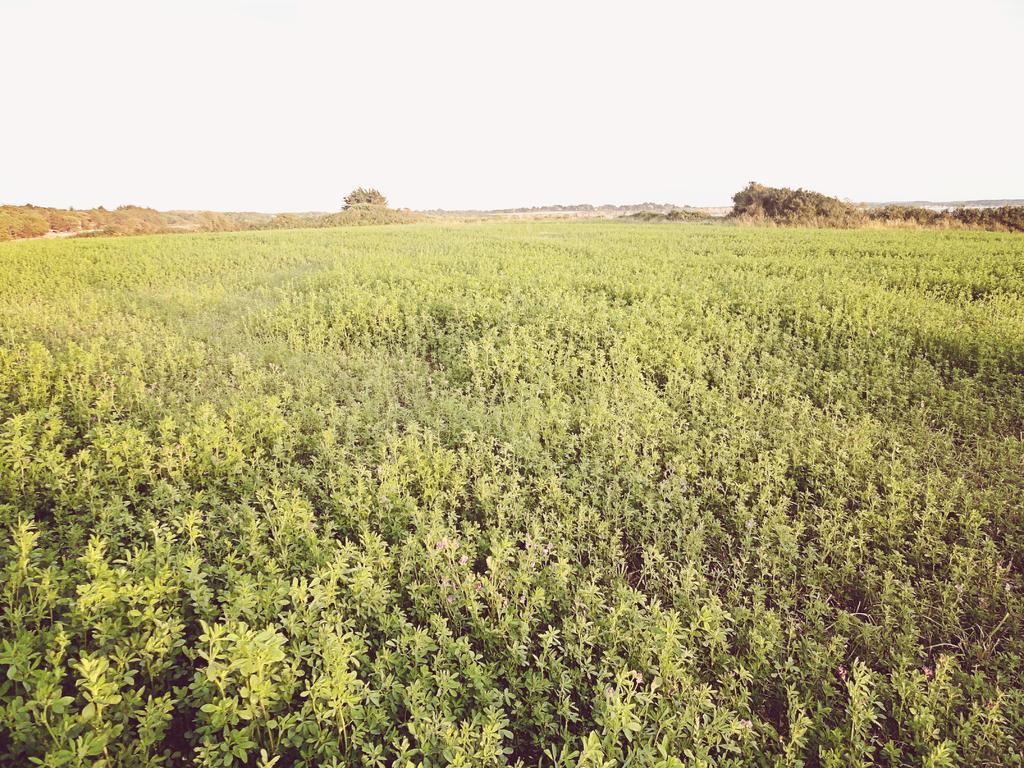In one or two sentences, can you explain what this image depicts? In this picture we can see farmland. At the bottom we can see plants and leaves. At the top we can see sky and clouds. In the background we can see mountain and trees. 